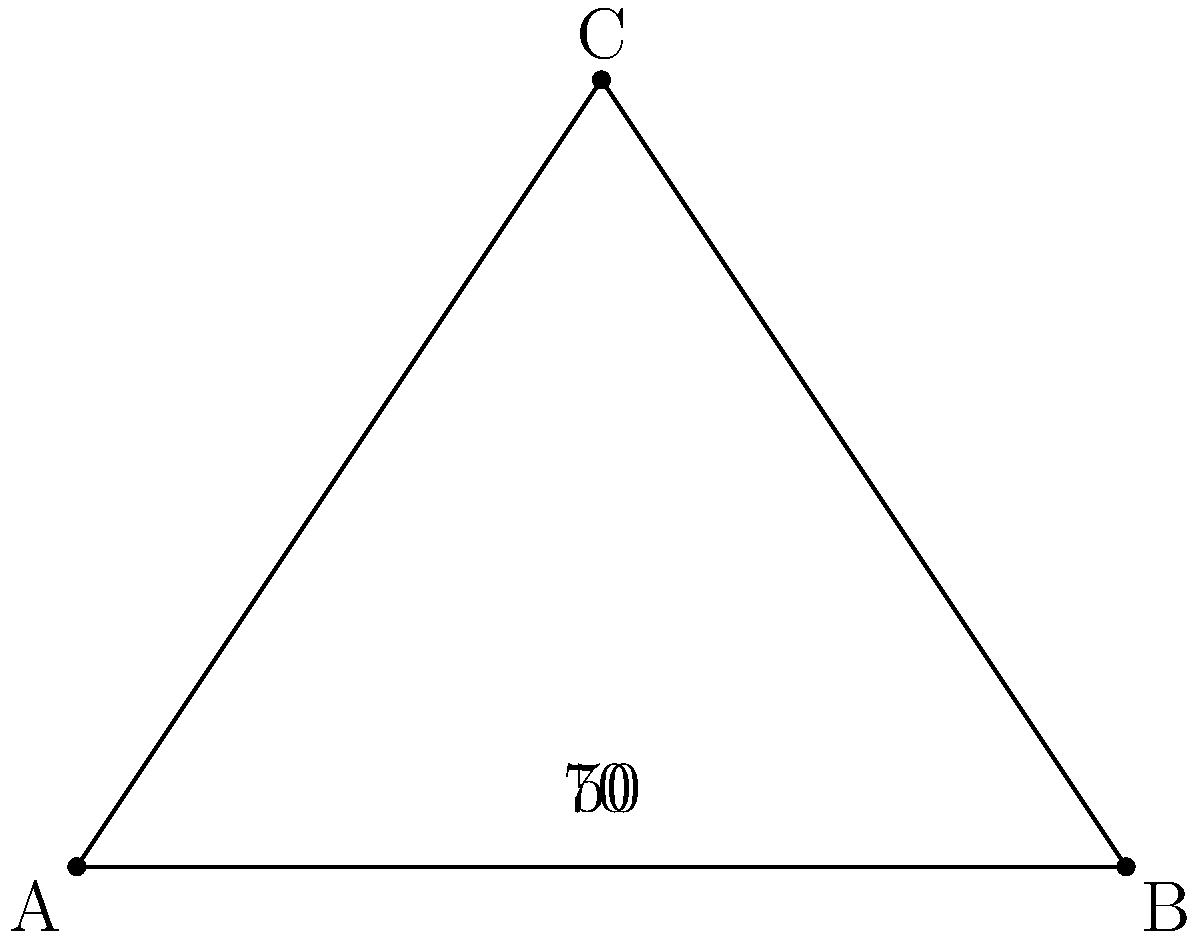On an ancient map of Roman roads, two major routes intersect at point C. The angle between these roads is represented by angle ACB in the diagram. If the angle BAC measures 50° and the angle ABC measures 70°, what is the measure of angle ACB? To find the measure of angle ACB, we can follow these steps:

1) First, recall that the sum of angles in a triangle is always 180°.

2) In this triangle ABC, we are given two angles:
   - Angle BAC = 50°
   - Angle ABC = 70°

3) Let's call the angle we're looking for (ACB) as x°.

4) We can set up an equation based on the fact that all angles in a triangle sum to 180°:
   
   $50° + 70° + x° = 180°$

5) Simplify the left side of the equation:
   
   $120° + x° = 180°$

6) Subtract 120° from both sides:
   
   $x° = 180° - 120° = 60°$

Therefore, the measure of angle ACB is 60°.
Answer: 60° 